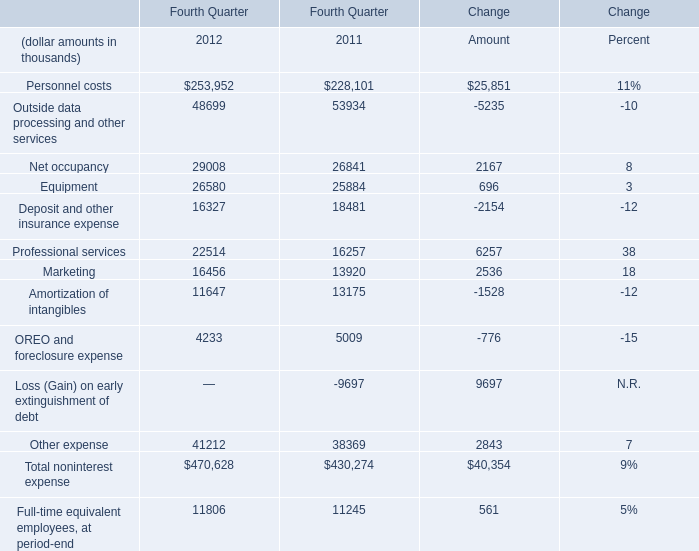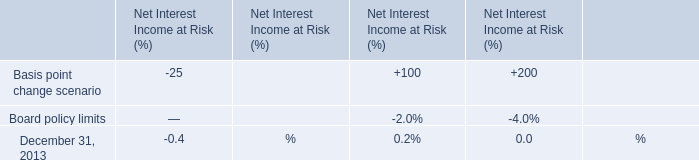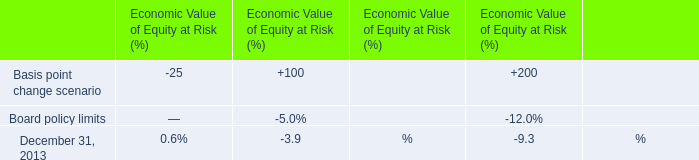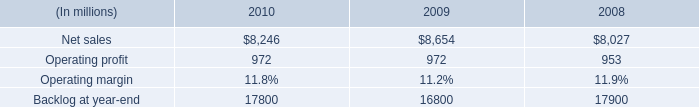what are the total operating expenses as a percentage of sales in 2010? 
Computations: ((8246 - 972) / 8246)
Answer: 0.88212. 